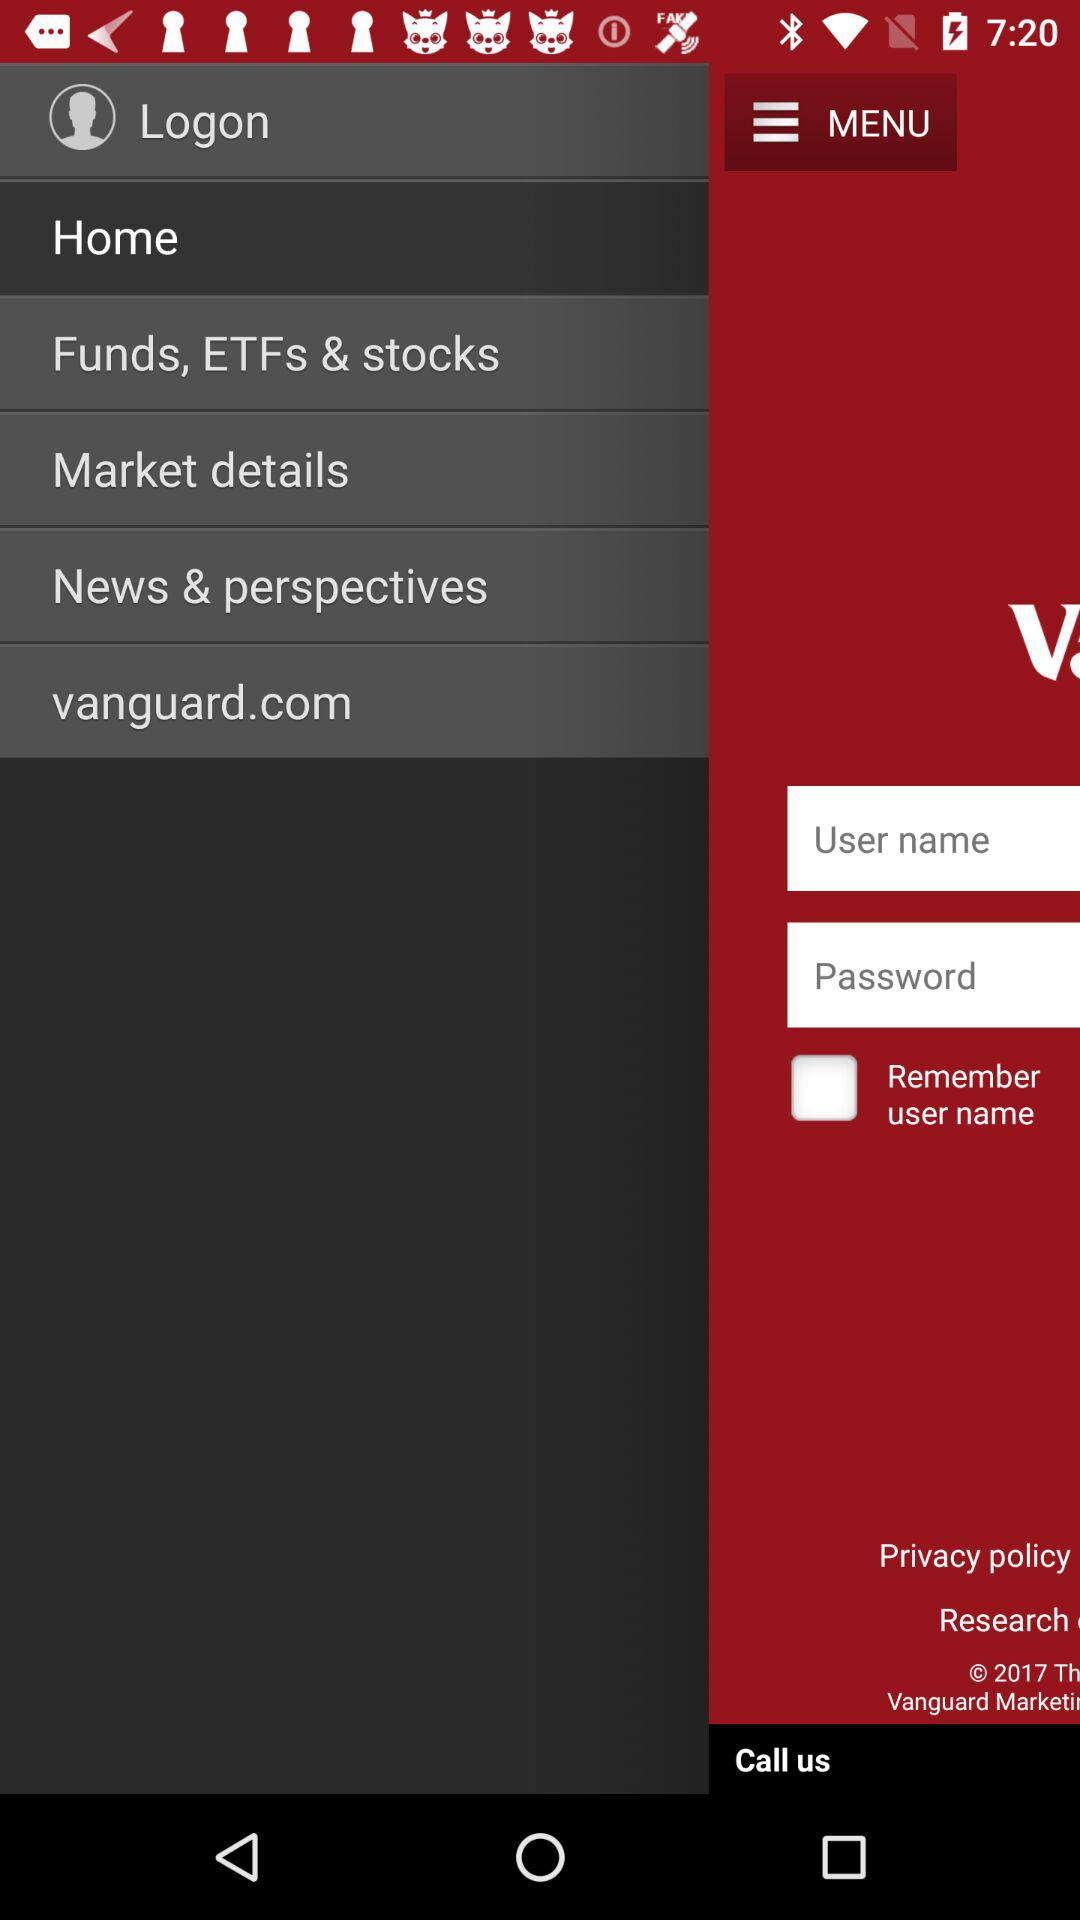What is the current status of the "Remember user name" setting? The status is off. 